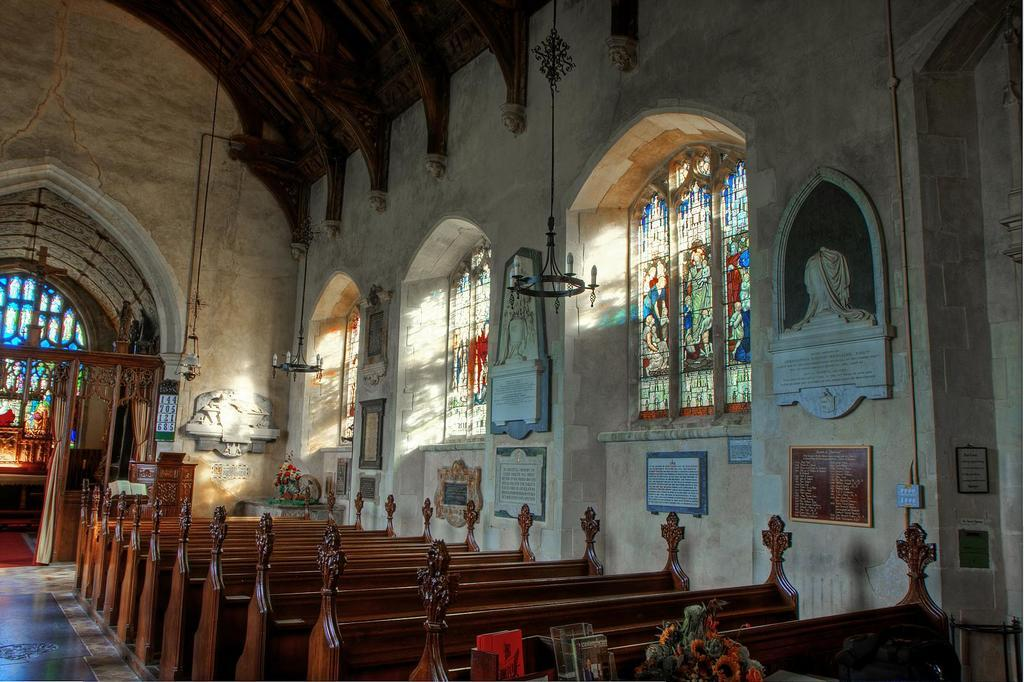What type of seating is located beside the wall in the image? There are benches beside the wall in the image. What architectural feature can be seen in the middle of the image? There is a window in the middle of the image. What type of tramp is visible in the image? There is no tramp present in the image. What type of expansion is shown in the image? The image does not depict any expansion; it only shows benches beside the wall and a window in the middle. 